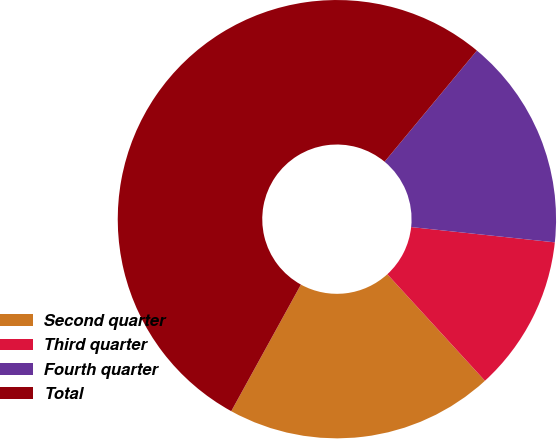<chart> <loc_0><loc_0><loc_500><loc_500><pie_chart><fcel>Second quarter<fcel>Third quarter<fcel>Fourth quarter<fcel>Total<nl><fcel>19.81%<fcel>11.51%<fcel>15.66%<fcel>53.02%<nl></chart> 